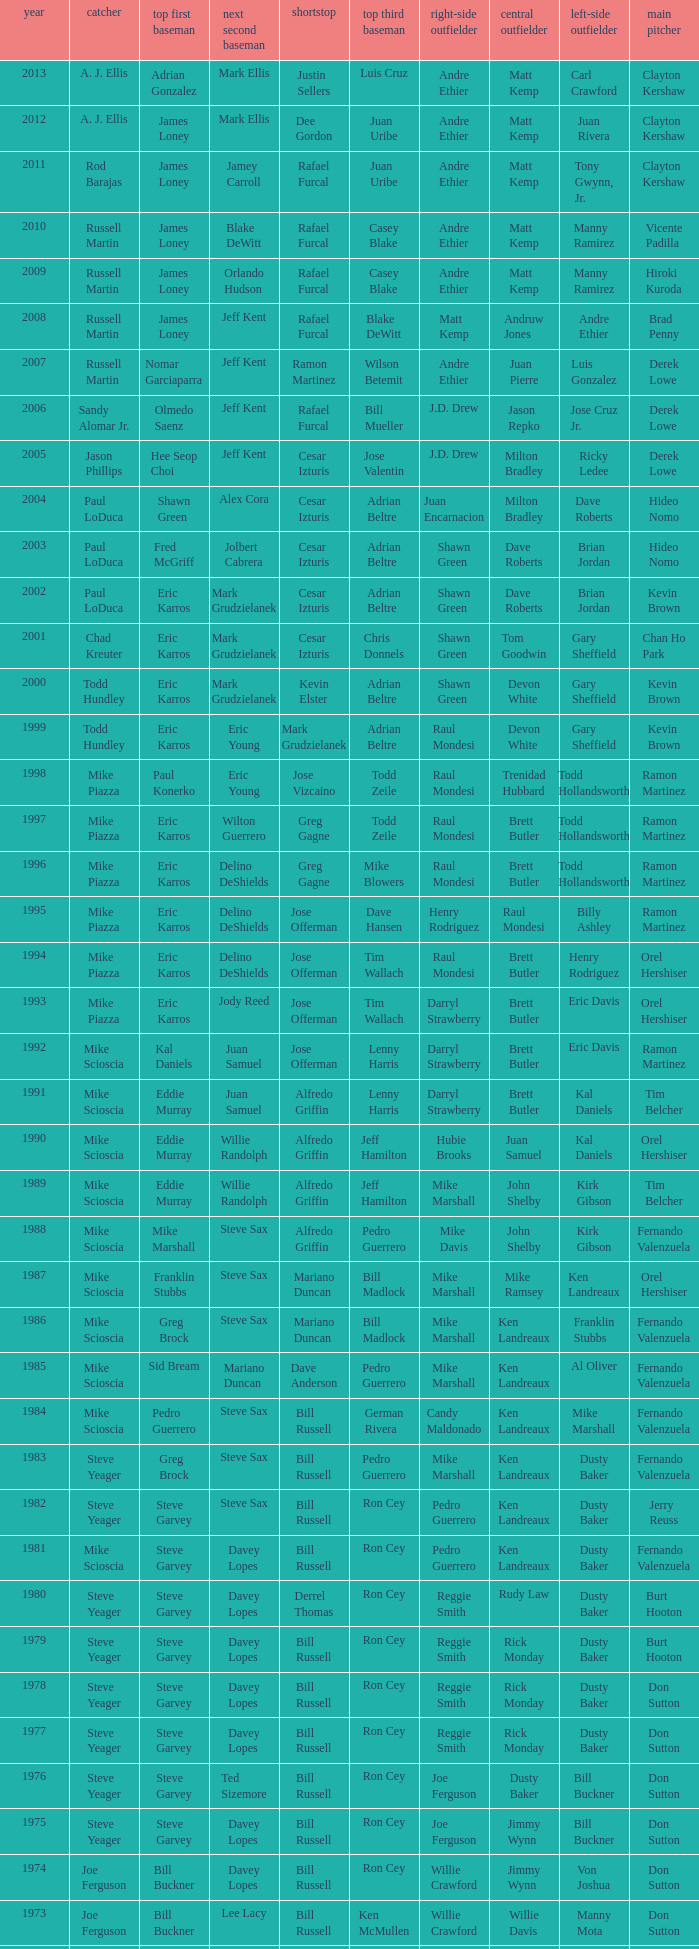Who was the RF when the SP was vicente padilla? Andre Ethier. 